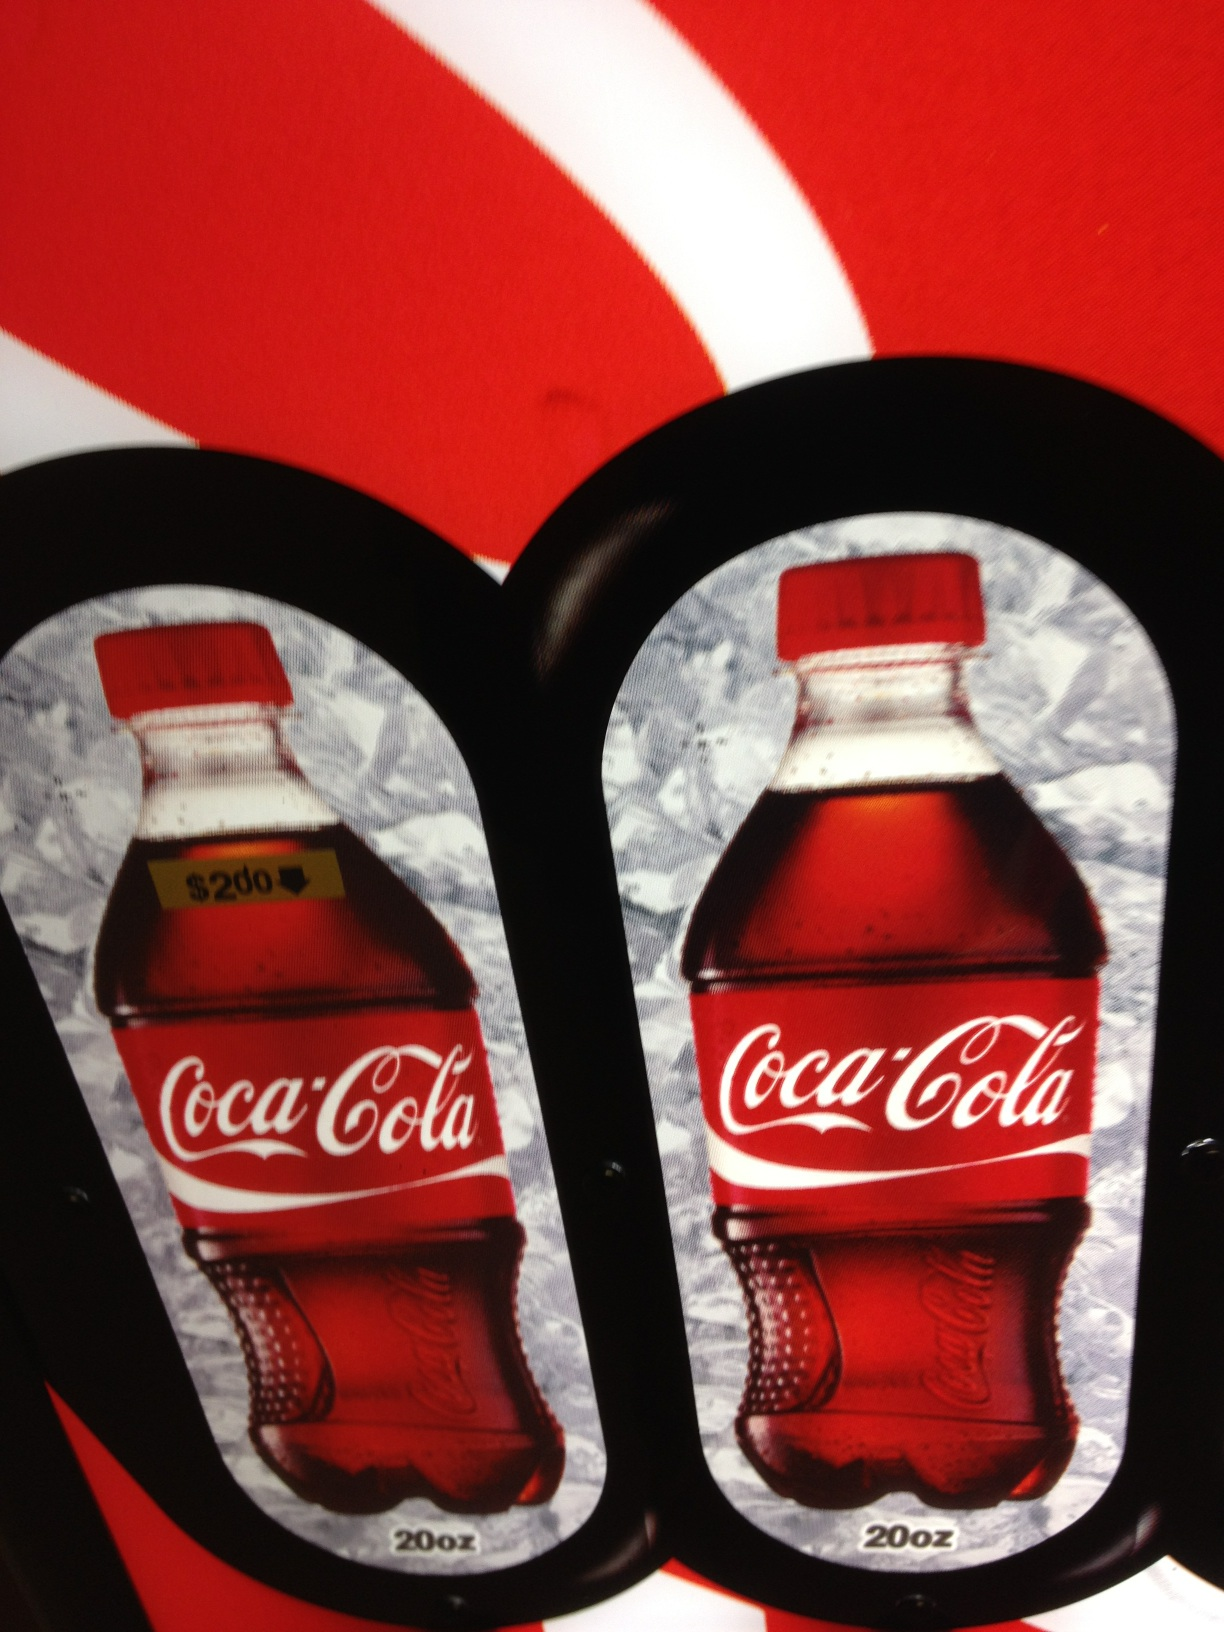Can you tell how many bottles are depicted in the image? The image displays two bottles of Coca-Cola. 